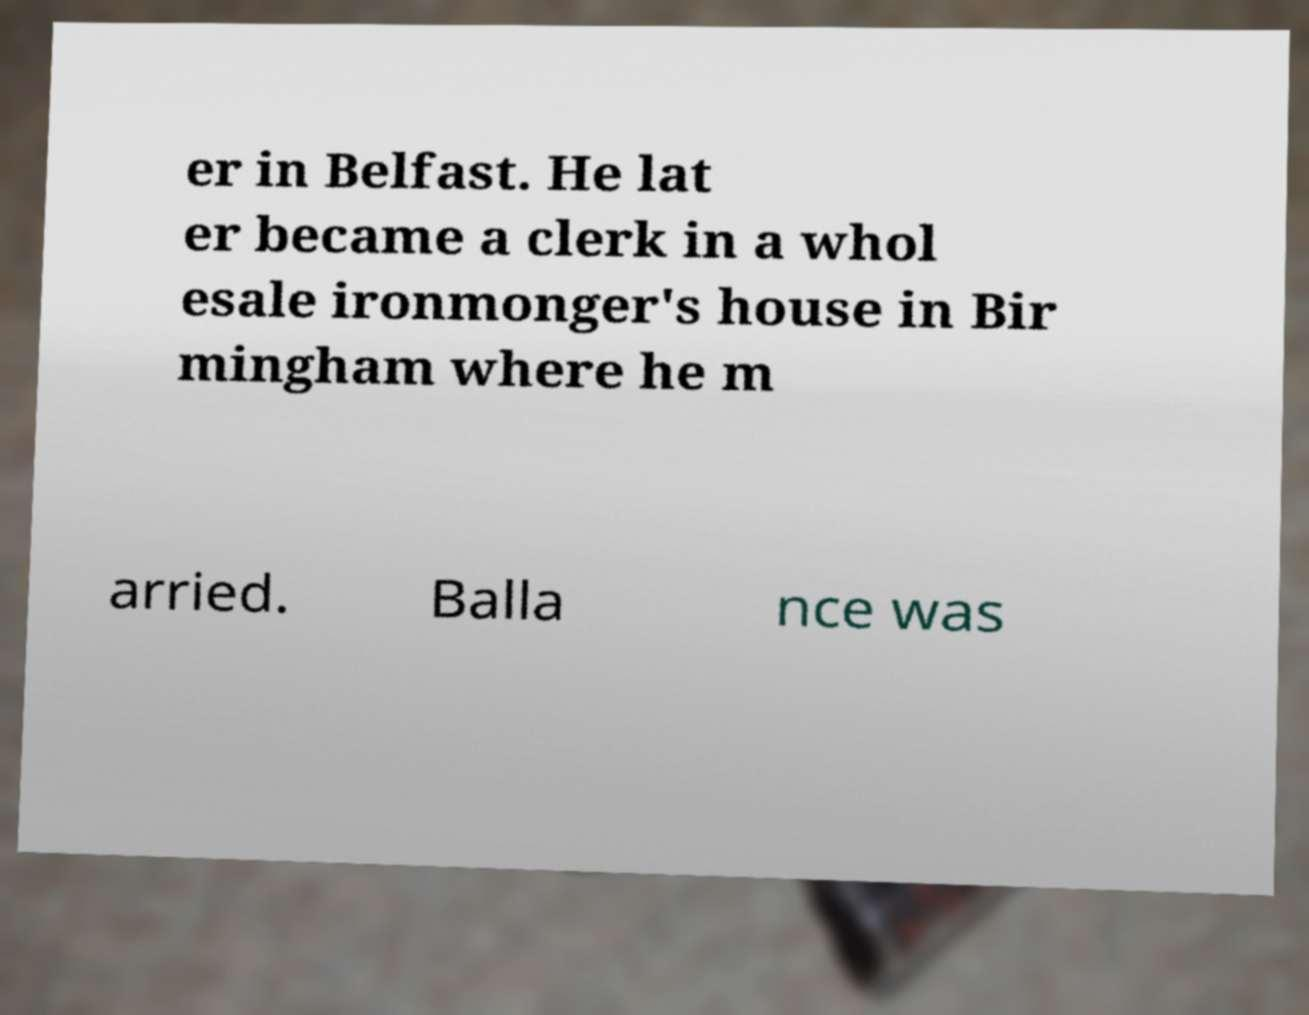Could you extract and type out the text from this image? er in Belfast. He lat er became a clerk in a whol esale ironmonger's house in Bir mingham where he m arried. Balla nce was 